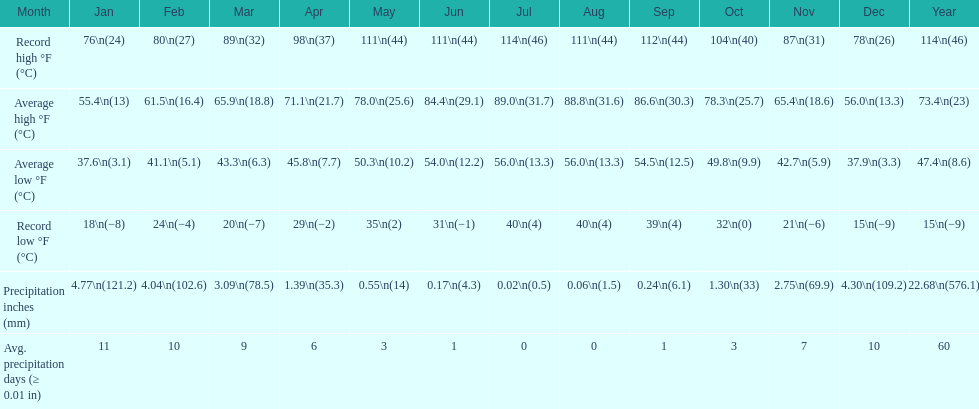In how many months is the record low beneath 25 degrees? 6. 